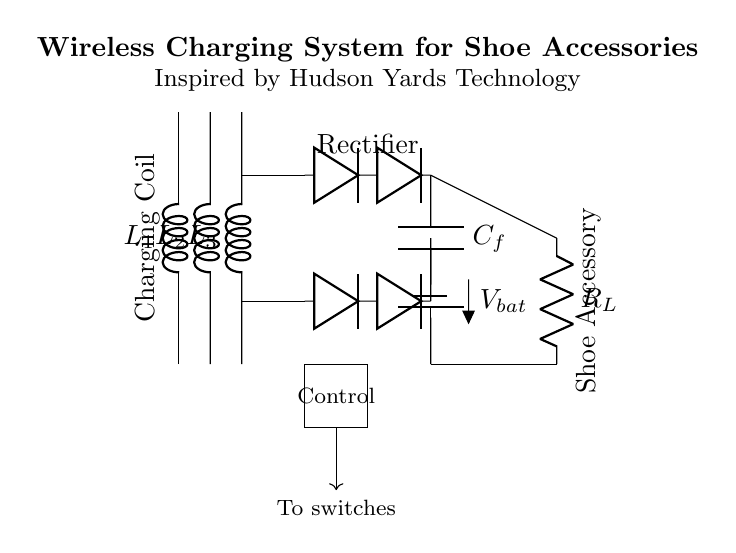What does the circuit provide power to? The circuit provides power to the shoe accessory, indicated by the load labeled as R_L.
Answer: Shoe accessory What are the components in the rectifier section? The rectifier consists of two diodes connected in series, as shown in the diagram.
Answer: Two diodes What is the purpose of the capacitor in the circuit? The capacitor, labeled as C_f, is used to smooth the output voltage from the rectifier and stabilize the power supply for the load.
Answer: Smoothing How many inductors are in the charging coil section? There are three inductors labeled L1, L2, and L3 in the charging coil section of the circuit diagram.
Answer: Three What type of control circuit is used in this design? The control circuit in this design is asynchronous, which means it operates independently of the main charging process.
Answer: Asynchronous How does the energy flow from the charging coil to the load? Energy flows from the charging coils through the rectifier, where it is converted to direct current, and then to the capacitor before reaching the load, R_L.
Answer: Through rectifier and capacitor 